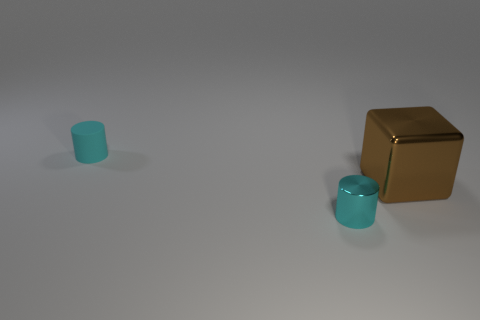There is a small cylinder behind the thing right of the shiny cylinder on the left side of the large brown object; what is its material?
Make the answer very short. Rubber. Are there the same number of small cyan things in front of the large brown cube and large blocks?
Provide a succinct answer. Yes. Is the cyan object behind the brown block made of the same material as the thing that is on the right side of the tiny metallic cylinder?
Your response must be concise. No. How many objects are either small matte objects or metallic things right of the tiny cyan metallic cylinder?
Make the answer very short. 2. Are there any brown things of the same shape as the small cyan rubber object?
Give a very brief answer. No. There is a brown block in front of the thing left of the cyan object in front of the brown object; what is its size?
Your response must be concise. Large. Are there an equal number of tiny metal cylinders to the right of the large brown block and cyan cylinders that are in front of the tiny rubber thing?
Your response must be concise. No. The big metallic object is what color?
Provide a succinct answer. Brown. How many cylinders have the same color as the shiny cube?
Offer a very short reply. 0. There is a object that is the same size as the metal cylinder; what is it made of?
Ensure brevity in your answer.  Rubber. 